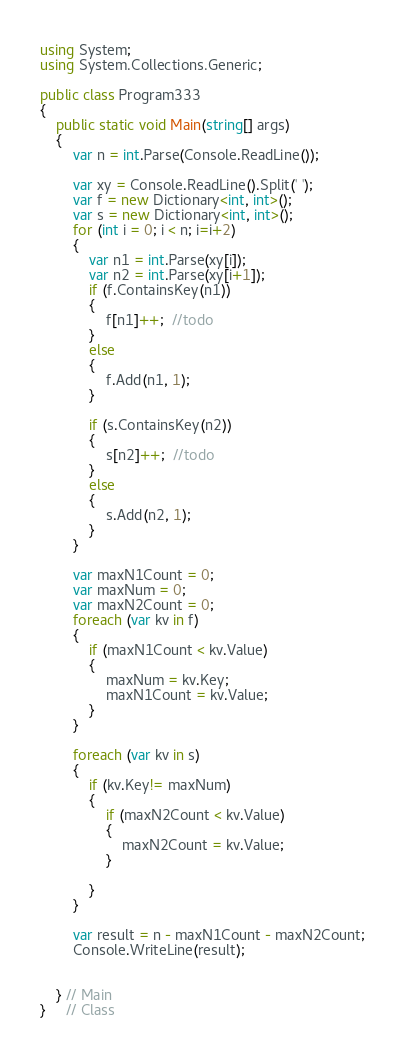<code> <loc_0><loc_0><loc_500><loc_500><_C#_>using System;
using System.Collections.Generic;

public class Program333
{
    public static void Main(string[] args)
    {
        var n = int.Parse(Console.ReadLine());

        var xy = Console.ReadLine().Split(' ');
        var f = new Dictionary<int, int>();
        var s = new Dictionary<int, int>();
        for (int i = 0; i < n; i=i+2)
        {
            var n1 = int.Parse(xy[i]);
            var n2 = int.Parse(xy[i+1]);
            if (f.ContainsKey(n1))
            {
                f[n1]++;  //todo
            }
            else
            {
                f.Add(n1, 1);
            }

            if (s.ContainsKey(n2))
            {
                s[n2]++;  //todo
            }
            else
            {
                s.Add(n2, 1);
            }
        }

        var maxN1Count = 0;
        var maxNum = 0;
        var maxN2Count = 0;
        foreach (var kv in f)
        {
            if (maxN1Count < kv.Value)
            {
                maxNum = kv.Key;
                maxN1Count = kv.Value;
            }
        }

        foreach (var kv in s)
        {
            if (kv.Key!= maxNum)
            {
                if (maxN2Count < kv.Value)
                {
                    maxN2Count = kv.Value;
                }

            }
        }

        var result = n - maxN1Count - maxN2Count;
        Console.WriteLine(result);


    } // Main
}     // Class



</code> 